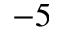<formula> <loc_0><loc_0><loc_500><loc_500>^ { - 5 }</formula> 